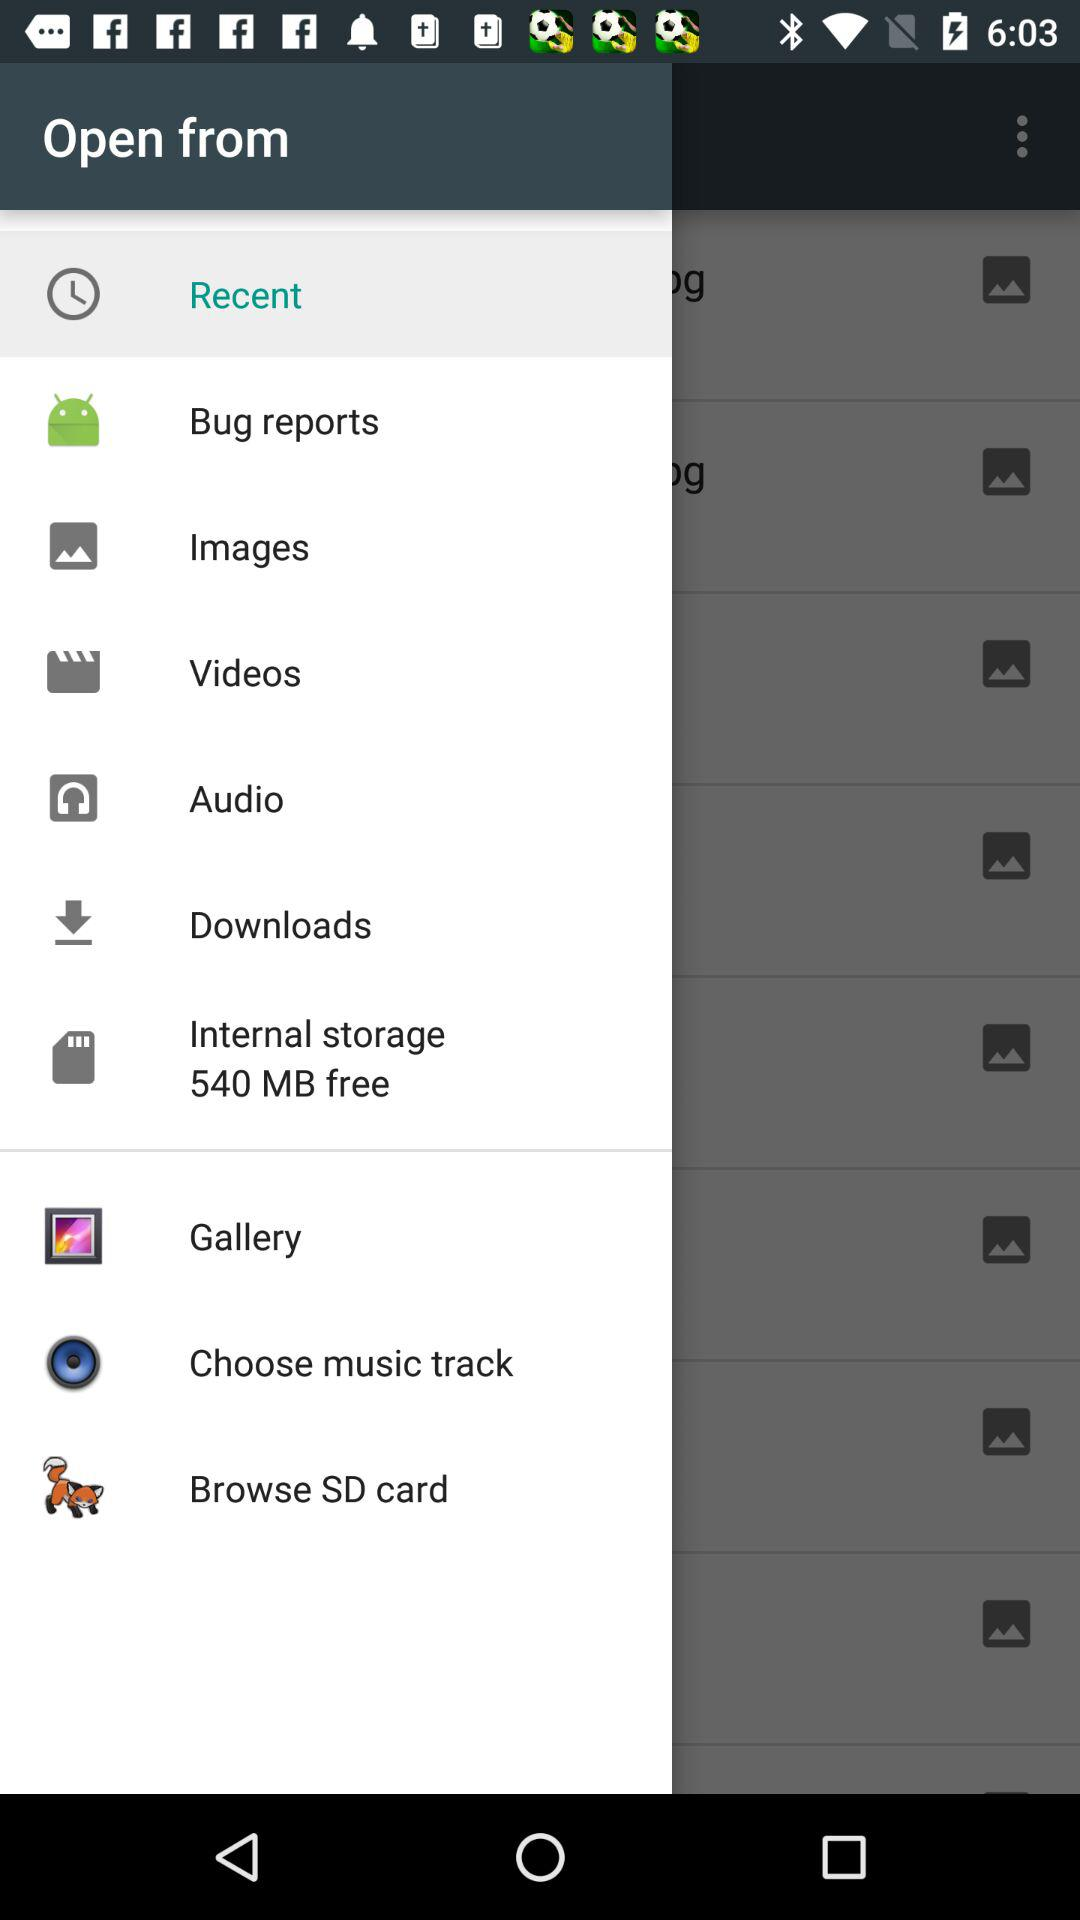How much internal storage is shown on the screen? There is 540 MB of free internal storage. 